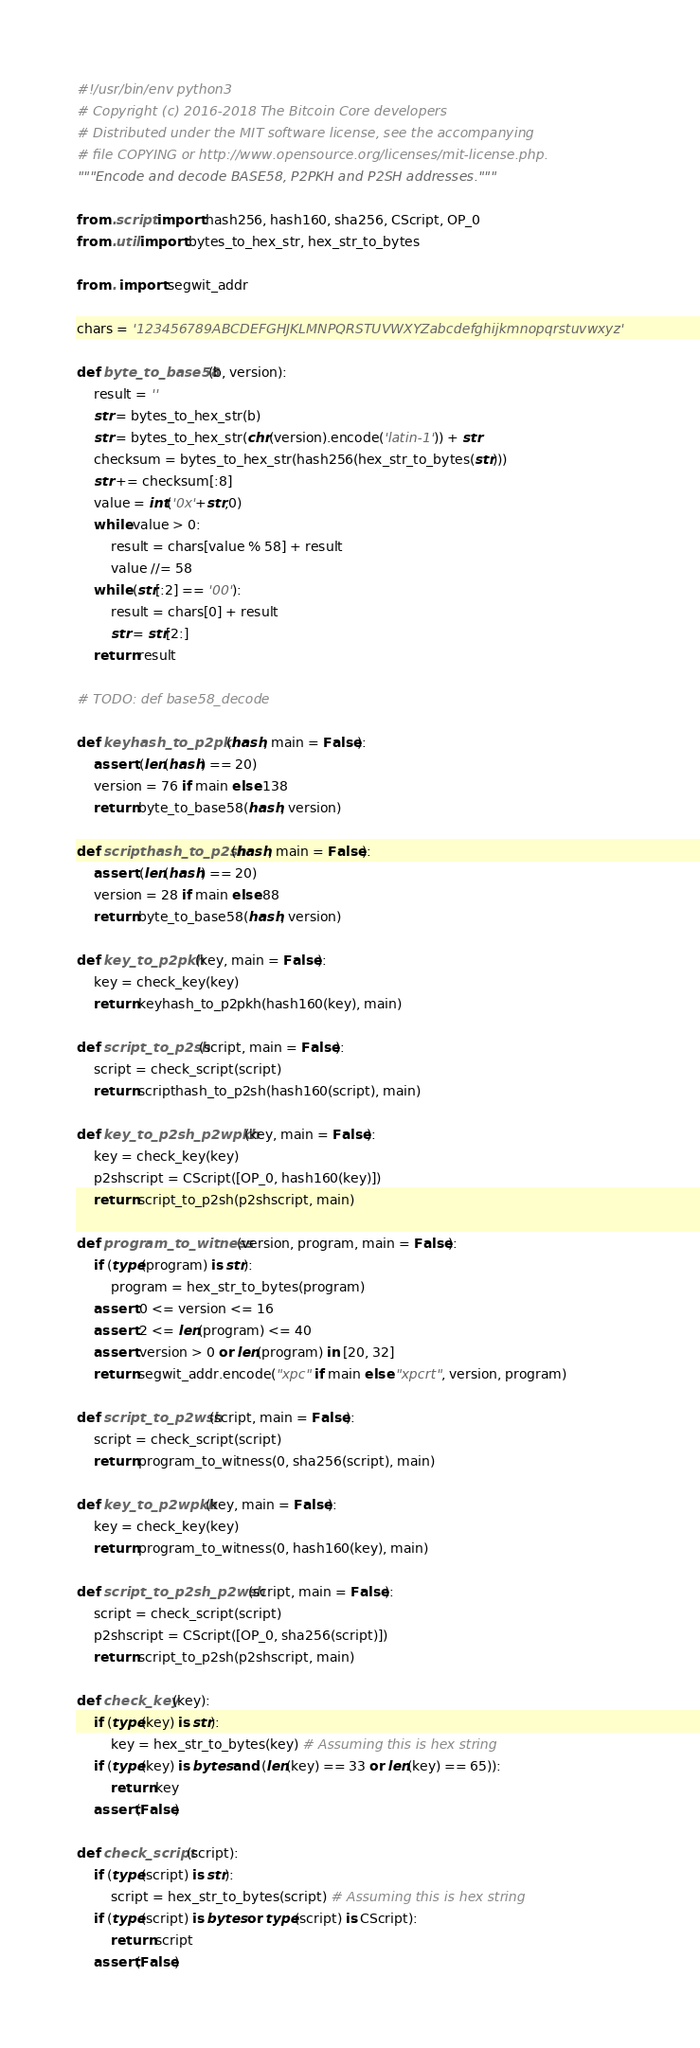<code> <loc_0><loc_0><loc_500><loc_500><_Python_>#!/usr/bin/env python3
# Copyright (c) 2016-2018 The Bitcoin Core developers
# Distributed under the MIT software license, see the accompanying
# file COPYING or http://www.opensource.org/licenses/mit-license.php.
"""Encode and decode BASE58, P2PKH and P2SH addresses."""

from .script import hash256, hash160, sha256, CScript, OP_0
from .util import bytes_to_hex_str, hex_str_to_bytes

from . import segwit_addr

chars = '123456789ABCDEFGHJKLMNPQRSTUVWXYZabcdefghijkmnopqrstuvwxyz'

def byte_to_base58(b, version):
    result = ''
    str = bytes_to_hex_str(b)
    str = bytes_to_hex_str(chr(version).encode('latin-1')) + str
    checksum = bytes_to_hex_str(hash256(hex_str_to_bytes(str)))
    str += checksum[:8]
    value = int('0x'+str,0)
    while value > 0:
        result = chars[value % 58] + result
        value //= 58
    while (str[:2] == '00'):
        result = chars[0] + result
        str = str[2:]
    return result

# TODO: def base58_decode

def keyhash_to_p2pkh(hash, main = False):
    assert (len(hash) == 20)
    version = 76 if main else 138
    return byte_to_base58(hash, version)

def scripthash_to_p2sh(hash, main = False):
    assert (len(hash) == 20)
    version = 28 if main else 88
    return byte_to_base58(hash, version)

def key_to_p2pkh(key, main = False):
    key = check_key(key)
    return keyhash_to_p2pkh(hash160(key), main)

def script_to_p2sh(script, main = False):
    script = check_script(script)
    return scripthash_to_p2sh(hash160(script), main)

def key_to_p2sh_p2wpkh(key, main = False):
    key = check_key(key)
    p2shscript = CScript([OP_0, hash160(key)])
    return script_to_p2sh(p2shscript, main)

def program_to_witness(version, program, main = False):
    if (type(program) is str):
        program = hex_str_to_bytes(program)
    assert 0 <= version <= 16
    assert 2 <= len(program) <= 40
    assert version > 0 or len(program) in [20, 32]
    return segwit_addr.encode("xpc" if main else "xpcrt", version, program)

def script_to_p2wsh(script, main = False):
    script = check_script(script)
    return program_to_witness(0, sha256(script), main)

def key_to_p2wpkh(key, main = False):
    key = check_key(key)
    return program_to_witness(0, hash160(key), main)

def script_to_p2sh_p2wsh(script, main = False):
    script = check_script(script)
    p2shscript = CScript([OP_0, sha256(script)])
    return script_to_p2sh(p2shscript, main)

def check_key(key):
    if (type(key) is str):
        key = hex_str_to_bytes(key) # Assuming this is hex string
    if (type(key) is bytes and (len(key) == 33 or len(key) == 65)):
        return key
    assert(False)

def check_script(script):
    if (type(script) is str):
        script = hex_str_to_bytes(script) # Assuming this is hex string
    if (type(script) is bytes or type(script) is CScript):
        return script
    assert(False)
</code> 